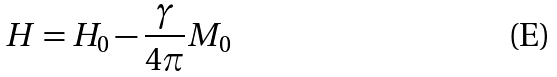Convert formula to latex. <formula><loc_0><loc_0><loc_500><loc_500>H = H _ { 0 } - \frac { \gamma } { 4 \pi } M _ { 0 }</formula> 